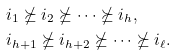<formula> <loc_0><loc_0><loc_500><loc_500>& i _ { 1 } \nsucceq i _ { 2 } \nsucceq \cdots \nsucceq i _ { h } , \\ & i _ { h + 1 } \nsucceq i _ { h + 2 } \nsucceq \cdots \nsucceq i _ { \ell } .</formula> 